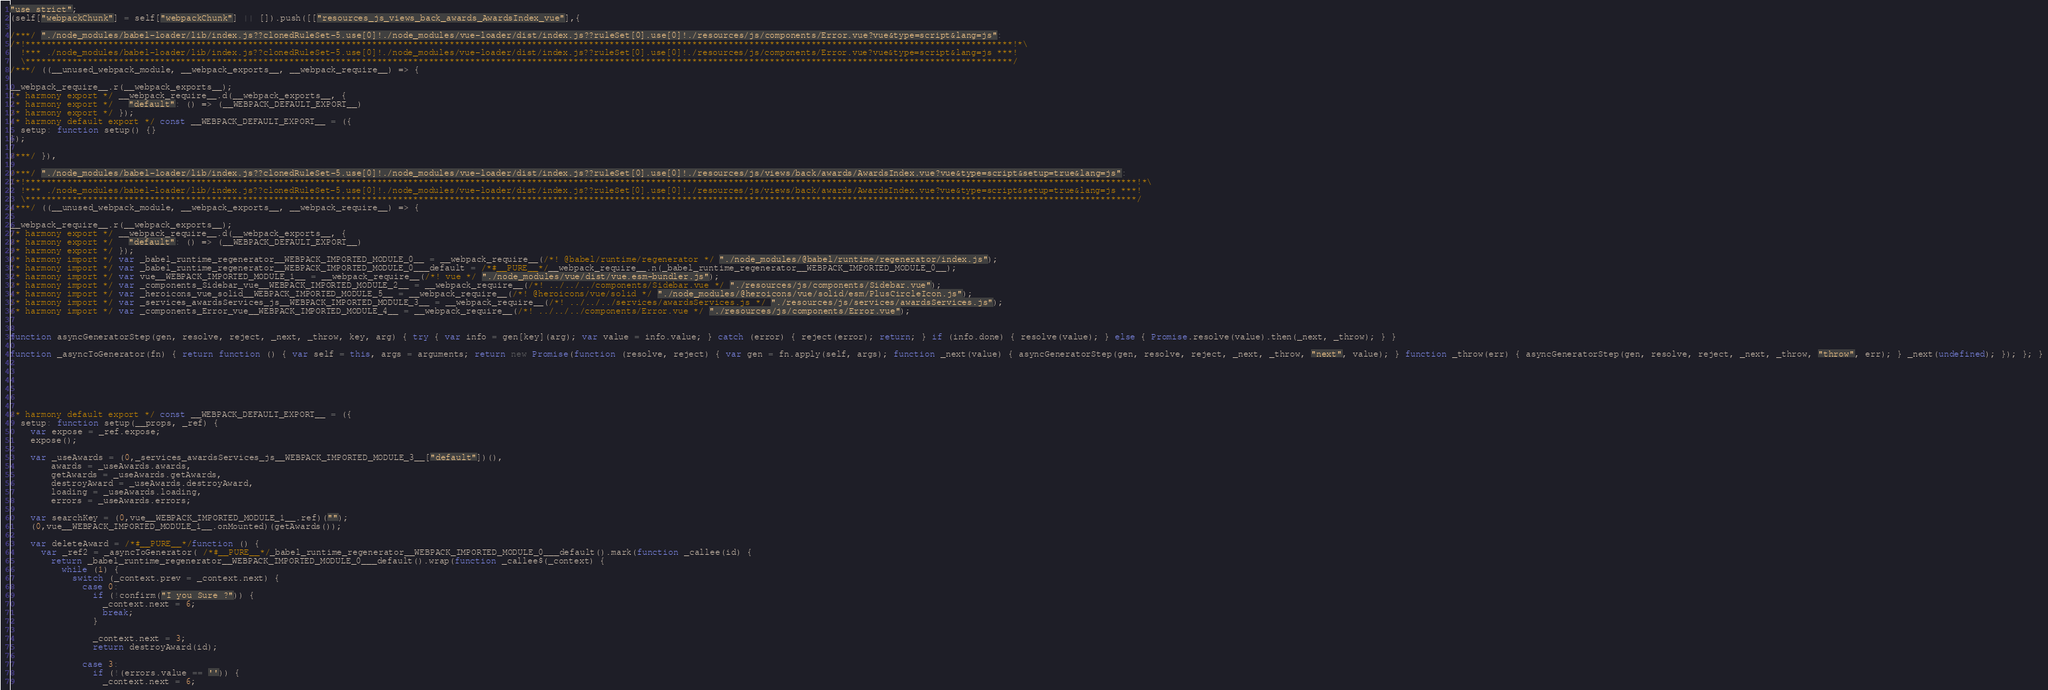Convert code to text. <code><loc_0><loc_0><loc_500><loc_500><_JavaScript_>"use strict";
(self["webpackChunk"] = self["webpackChunk"] || []).push([["resources_js_views_back_awards_AwardsIndex_vue"],{

/***/ "./node_modules/babel-loader/lib/index.js??clonedRuleSet-5.use[0]!./node_modules/vue-loader/dist/index.js??ruleSet[0].use[0]!./resources/js/components/Error.vue?vue&type=script&lang=js":
/*!***********************************************************************************************************************************************************************************************!*\
  !*** ./node_modules/babel-loader/lib/index.js??clonedRuleSet-5.use[0]!./node_modules/vue-loader/dist/index.js??ruleSet[0].use[0]!./resources/js/components/Error.vue?vue&type=script&lang=js ***!
  \***********************************************************************************************************************************************************************************************/
/***/ ((__unused_webpack_module, __webpack_exports__, __webpack_require__) => {

__webpack_require__.r(__webpack_exports__);
/* harmony export */ __webpack_require__.d(__webpack_exports__, {
/* harmony export */   "default": () => (__WEBPACK_DEFAULT_EXPORT__)
/* harmony export */ });
/* harmony default export */ const __WEBPACK_DEFAULT_EXPORT__ = ({
  setup: function setup() {}
});

/***/ }),

/***/ "./node_modules/babel-loader/lib/index.js??clonedRuleSet-5.use[0]!./node_modules/vue-loader/dist/index.js??ruleSet[0].use[0]!./resources/js/views/back/awards/AwardsIndex.vue?vue&type=script&setup=true&lang=js":
/*!***********************************************************************************************************************************************************************************************************************!*\
  !*** ./node_modules/babel-loader/lib/index.js??clonedRuleSet-5.use[0]!./node_modules/vue-loader/dist/index.js??ruleSet[0].use[0]!./resources/js/views/back/awards/AwardsIndex.vue?vue&type=script&setup=true&lang=js ***!
  \***********************************************************************************************************************************************************************************************************************/
/***/ ((__unused_webpack_module, __webpack_exports__, __webpack_require__) => {

__webpack_require__.r(__webpack_exports__);
/* harmony export */ __webpack_require__.d(__webpack_exports__, {
/* harmony export */   "default": () => (__WEBPACK_DEFAULT_EXPORT__)
/* harmony export */ });
/* harmony import */ var _babel_runtime_regenerator__WEBPACK_IMPORTED_MODULE_0__ = __webpack_require__(/*! @babel/runtime/regenerator */ "./node_modules/@babel/runtime/regenerator/index.js");
/* harmony import */ var _babel_runtime_regenerator__WEBPACK_IMPORTED_MODULE_0___default = /*#__PURE__*/__webpack_require__.n(_babel_runtime_regenerator__WEBPACK_IMPORTED_MODULE_0__);
/* harmony import */ var vue__WEBPACK_IMPORTED_MODULE_1__ = __webpack_require__(/*! vue */ "./node_modules/vue/dist/vue.esm-bundler.js");
/* harmony import */ var _components_Sidebar_vue__WEBPACK_IMPORTED_MODULE_2__ = __webpack_require__(/*! ../../../components/Sidebar.vue */ "./resources/js/components/Sidebar.vue");
/* harmony import */ var _heroicons_vue_solid__WEBPACK_IMPORTED_MODULE_5__ = __webpack_require__(/*! @heroicons/vue/solid */ "./node_modules/@heroicons/vue/solid/esm/PlusCircleIcon.js");
/* harmony import */ var _services_awardsServices_js__WEBPACK_IMPORTED_MODULE_3__ = __webpack_require__(/*! ../../../services/awardsServices.js */ "./resources/js/services/awardsServices.js");
/* harmony import */ var _components_Error_vue__WEBPACK_IMPORTED_MODULE_4__ = __webpack_require__(/*! ../../../components/Error.vue */ "./resources/js/components/Error.vue");


function asyncGeneratorStep(gen, resolve, reject, _next, _throw, key, arg) { try { var info = gen[key](arg); var value = info.value; } catch (error) { reject(error); return; } if (info.done) { resolve(value); } else { Promise.resolve(value).then(_next, _throw); } }

function _asyncToGenerator(fn) { return function () { var self = this, args = arguments; return new Promise(function (resolve, reject) { var gen = fn.apply(self, args); function _next(value) { asyncGeneratorStep(gen, resolve, reject, _next, _throw, "next", value); } function _throw(err) { asyncGeneratorStep(gen, resolve, reject, _next, _throw, "throw", err); } _next(undefined); }); }; }






/* harmony default export */ const __WEBPACK_DEFAULT_EXPORT__ = ({
  setup: function setup(__props, _ref) {
    var expose = _ref.expose;
    expose();

    var _useAwards = (0,_services_awardsServices_js__WEBPACK_IMPORTED_MODULE_3__["default"])(),
        awards = _useAwards.awards,
        getAwards = _useAwards.getAwards,
        destroyAward = _useAwards.destroyAward,
        loading = _useAwards.loading,
        errors = _useAwards.errors;

    var searchKey = (0,vue__WEBPACK_IMPORTED_MODULE_1__.ref)("");
    (0,vue__WEBPACK_IMPORTED_MODULE_1__.onMounted)(getAwards());

    var deleteAward = /*#__PURE__*/function () {
      var _ref2 = _asyncToGenerator( /*#__PURE__*/_babel_runtime_regenerator__WEBPACK_IMPORTED_MODULE_0___default().mark(function _callee(id) {
        return _babel_runtime_regenerator__WEBPACK_IMPORTED_MODULE_0___default().wrap(function _callee$(_context) {
          while (1) {
            switch (_context.prev = _context.next) {
              case 0:
                if (!confirm("I you Sure ?")) {
                  _context.next = 6;
                  break;
                }

                _context.next = 3;
                return destroyAward(id);

              case 3:
                if (!(errors.value == '')) {
                  _context.next = 6;</code> 